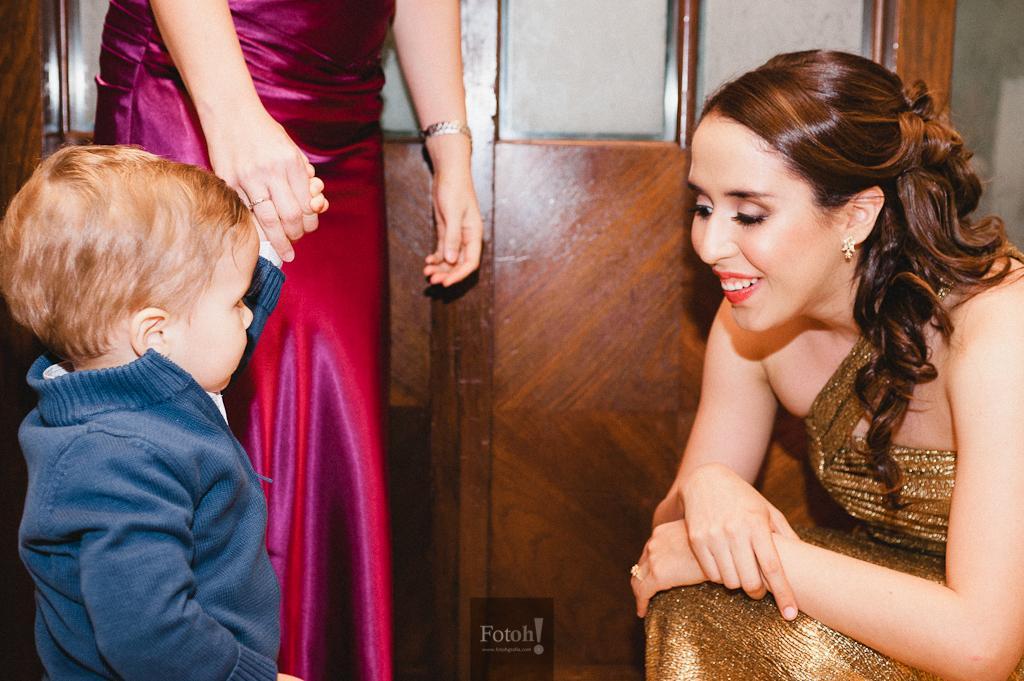Could you give a brief overview of what you see in this image? In this image there is a boy wearing a blue jacket. Beside there is a person standing near the wall. Right side there is a woman. 